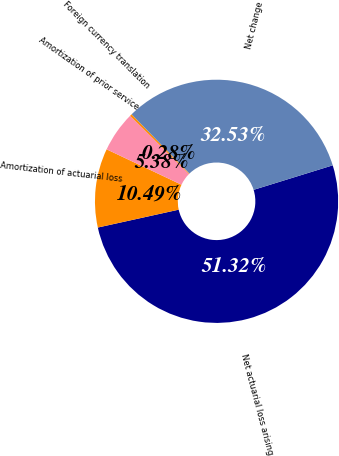Convert chart. <chart><loc_0><loc_0><loc_500><loc_500><pie_chart><fcel>Net actuarial loss arising<fcel>Amortization of actuarial loss<fcel>Amortization of prior service<fcel>Foreign currency translation<fcel>Net change<nl><fcel>51.32%<fcel>10.49%<fcel>5.38%<fcel>0.28%<fcel>32.53%<nl></chart> 